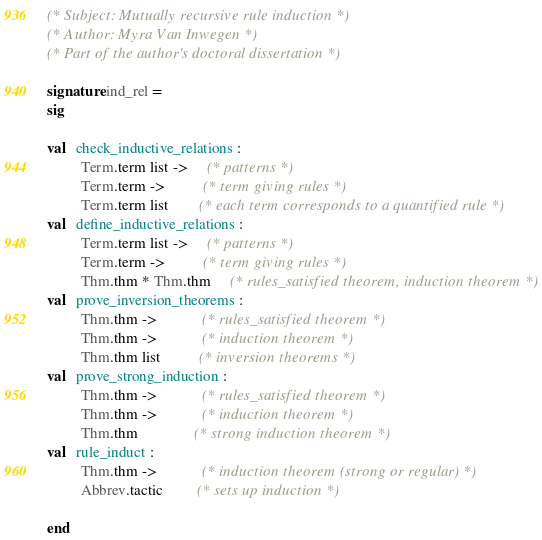<code> <loc_0><loc_0><loc_500><loc_500><_SML_>(* Subject: Mutually recursive rule induction *)
(* Author: Myra Van Inwegen *)
(* Part of the author's doctoral dissertation *)

signature ind_rel =
sig

val   check_inductive_relations :
         Term.term list ->     (* patterns *)
         Term.term ->          (* term giving rules *)
         Term.term list        (* each term corresponds to a quantified rule *)
val   define_inductive_relations :
         Term.term list ->     (* patterns *)
         Term.term ->          (* term giving rules *)
         Thm.thm * Thm.thm     (* rules_satisfied theorem, induction theorem *)
val   prove_inversion_theorems :
         Thm.thm ->            (* rules_satisfied theorem *)
         Thm.thm ->            (* induction theorem *)
         Thm.thm list          (* inversion theorems *)
val   prove_strong_induction :
         Thm.thm ->            (* rules_satisfied theorem *)
         Thm.thm ->            (* induction theorem *)
         Thm.thm               (* strong induction theorem *)
val   rule_induct :
         Thm.thm ->            (* induction theorem (strong or regular) *)
         Abbrev.tactic         (* sets up induction *)

end
</code> 